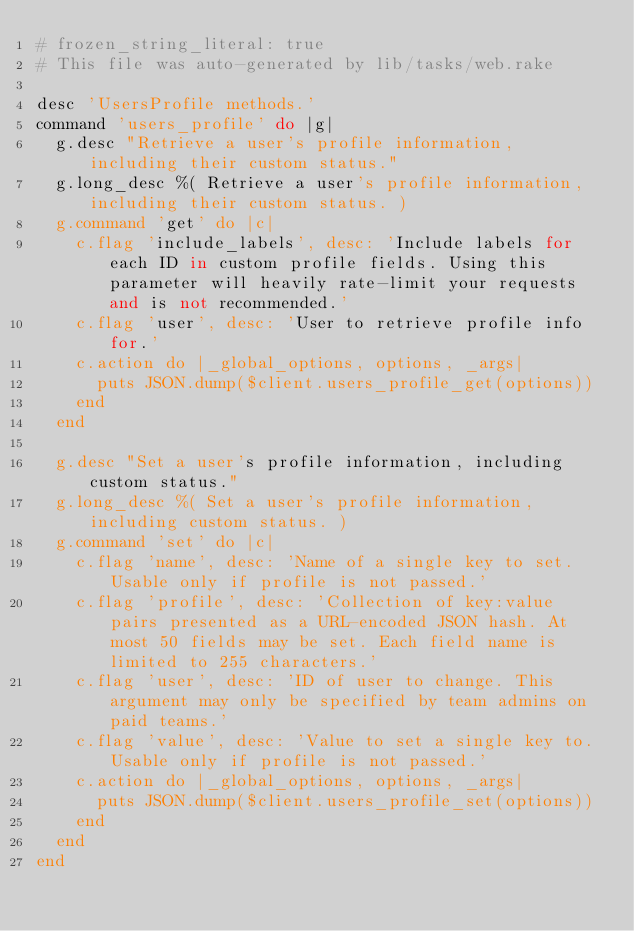Convert code to text. <code><loc_0><loc_0><loc_500><loc_500><_Ruby_># frozen_string_literal: true
# This file was auto-generated by lib/tasks/web.rake

desc 'UsersProfile methods.'
command 'users_profile' do |g|
  g.desc "Retrieve a user's profile information, including their custom status."
  g.long_desc %( Retrieve a user's profile information, including their custom status. )
  g.command 'get' do |c|
    c.flag 'include_labels', desc: 'Include labels for each ID in custom profile fields. Using this parameter will heavily rate-limit your requests and is not recommended.'
    c.flag 'user', desc: 'User to retrieve profile info for.'
    c.action do |_global_options, options, _args|
      puts JSON.dump($client.users_profile_get(options))
    end
  end

  g.desc "Set a user's profile information, including custom status."
  g.long_desc %( Set a user's profile information, including custom status. )
  g.command 'set' do |c|
    c.flag 'name', desc: 'Name of a single key to set. Usable only if profile is not passed.'
    c.flag 'profile', desc: 'Collection of key:value pairs presented as a URL-encoded JSON hash. At most 50 fields may be set. Each field name is limited to 255 characters.'
    c.flag 'user', desc: 'ID of user to change. This argument may only be specified by team admins on paid teams.'
    c.flag 'value', desc: 'Value to set a single key to. Usable only if profile is not passed.'
    c.action do |_global_options, options, _args|
      puts JSON.dump($client.users_profile_set(options))
    end
  end
end
</code> 